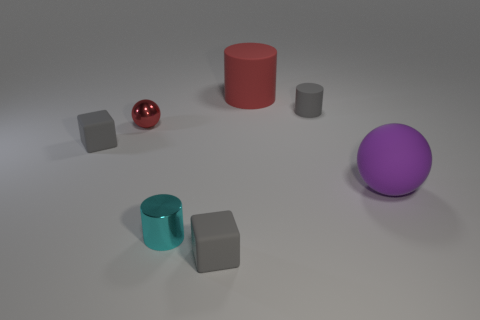There is a object that is the same color as the large rubber cylinder; what is it made of?
Provide a succinct answer. Metal. Does the large thing that is left of the gray matte cylinder have the same color as the tiny metal object behind the cyan object?
Provide a succinct answer. Yes. Are the big cylinder and the large purple object made of the same material?
Your answer should be very brief. Yes. How many big yellow shiny cylinders are there?
Offer a terse response. 0. What is the color of the large matte thing in front of the big rubber object behind the small gray thing that is right of the large matte cylinder?
Your answer should be very brief. Purple. Does the large matte cylinder have the same color as the rubber sphere?
Make the answer very short. No. How many cylinders are to the right of the red matte cylinder and to the left of the large red matte cylinder?
Make the answer very short. 0. What number of shiny things are either tiny gray cubes or small gray balls?
Make the answer very short. 0. There is a gray object that is in front of the metal thing that is in front of the purple object; what is its material?
Your response must be concise. Rubber. There is a rubber thing that is the same color as the small ball; what is its shape?
Offer a very short reply. Cylinder. 